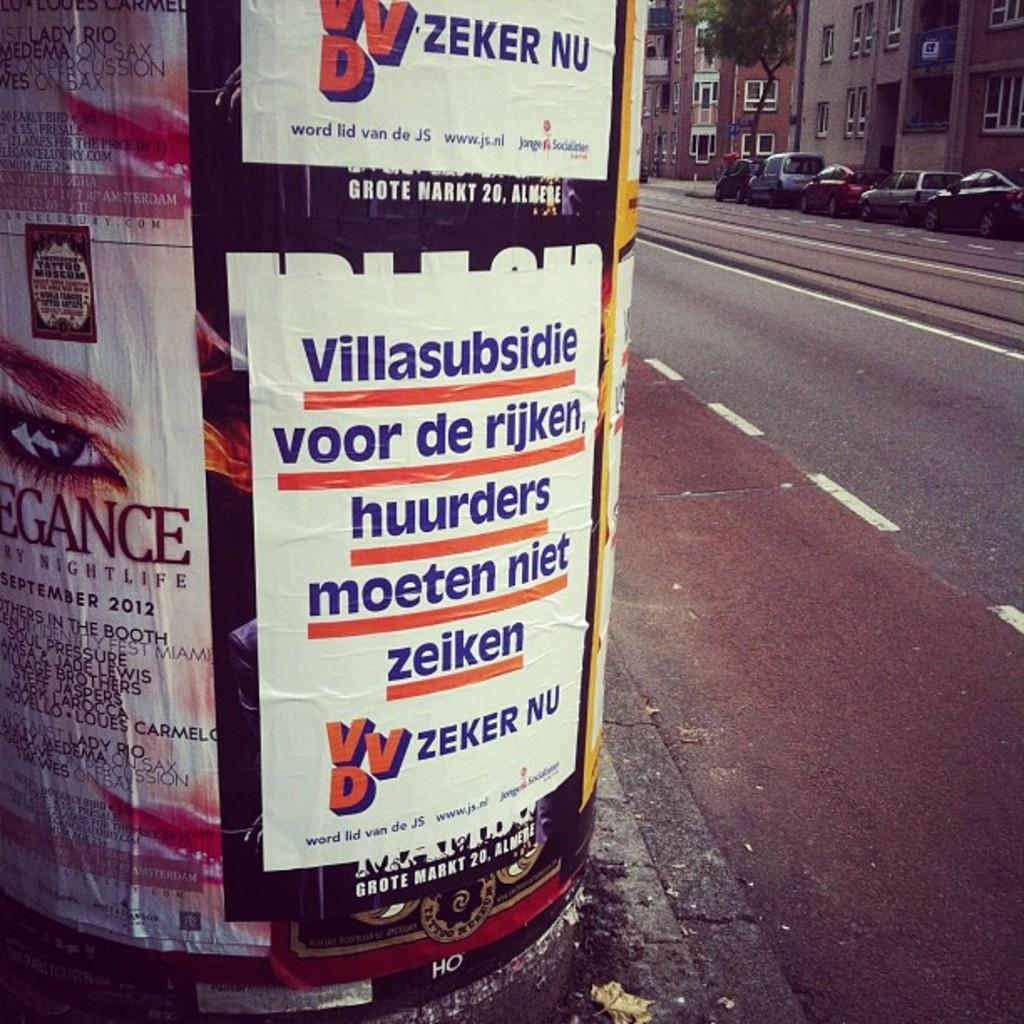<image>
Present a compact description of the photo's key features. A white poster says Zeker Nu at the bottom of it. 